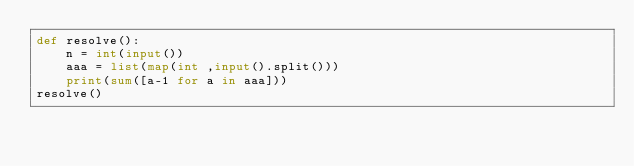<code> <loc_0><loc_0><loc_500><loc_500><_Python_>def resolve():
    n = int(input())
    aaa = list(map(int ,input().split()))
    print(sum([a-1 for a in aaa]))
resolve()</code> 